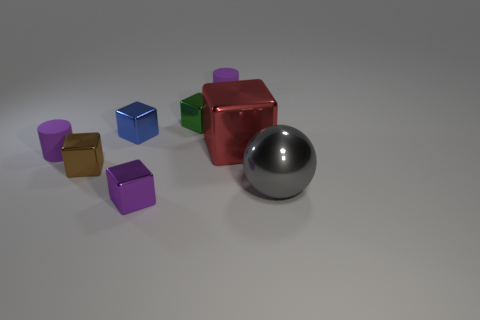Is there any other thing that is the same shape as the gray thing?
Offer a very short reply. No. How many blue metallic objects have the same shape as the big red metallic object?
Your response must be concise. 1. What number of objects are big metal blocks or purple objects that are in front of the big red metallic block?
Offer a very short reply. 3. What material is the large red block?
Keep it short and to the point. Metal. There is a red thing that is the same shape as the tiny blue object; what is it made of?
Make the answer very short. Metal. What is the color of the shiny cube behind the small blue object that is behind the brown metallic object?
Provide a succinct answer. Green. What number of metal objects are either cyan spheres or large balls?
Provide a short and direct response. 1. What material is the large object that is behind the purple rubber object in front of the big block made of?
Your response must be concise. Metal. How many small things are gray objects or green rubber spheres?
Offer a very short reply. 0. What is the size of the sphere?
Ensure brevity in your answer.  Large. 